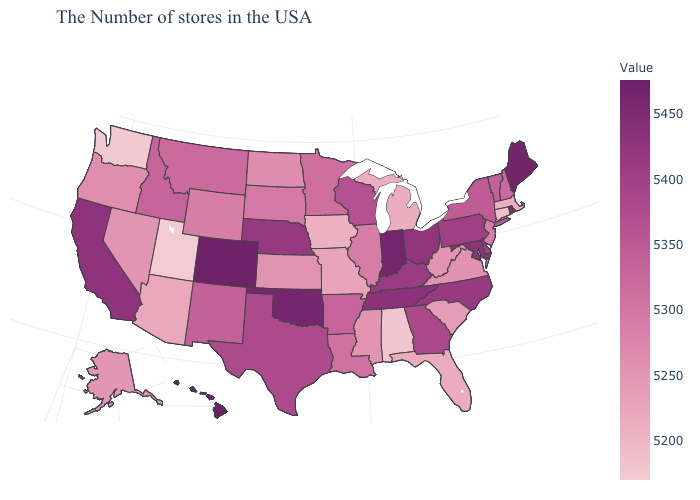Among the states that border Oklahoma , does Missouri have the highest value?
Give a very brief answer. No. Does the map have missing data?
Give a very brief answer. No. Which states have the lowest value in the West?
Keep it brief. Utah. Does New York have the highest value in the Northeast?
Short answer required. No. Which states have the highest value in the USA?
Write a very short answer. Hawaii. Does South Dakota have a lower value than Arizona?
Answer briefly. No. Does the map have missing data?
Quick response, please. No. Among the states that border Colorado , does Utah have the lowest value?
Be succinct. Yes. 